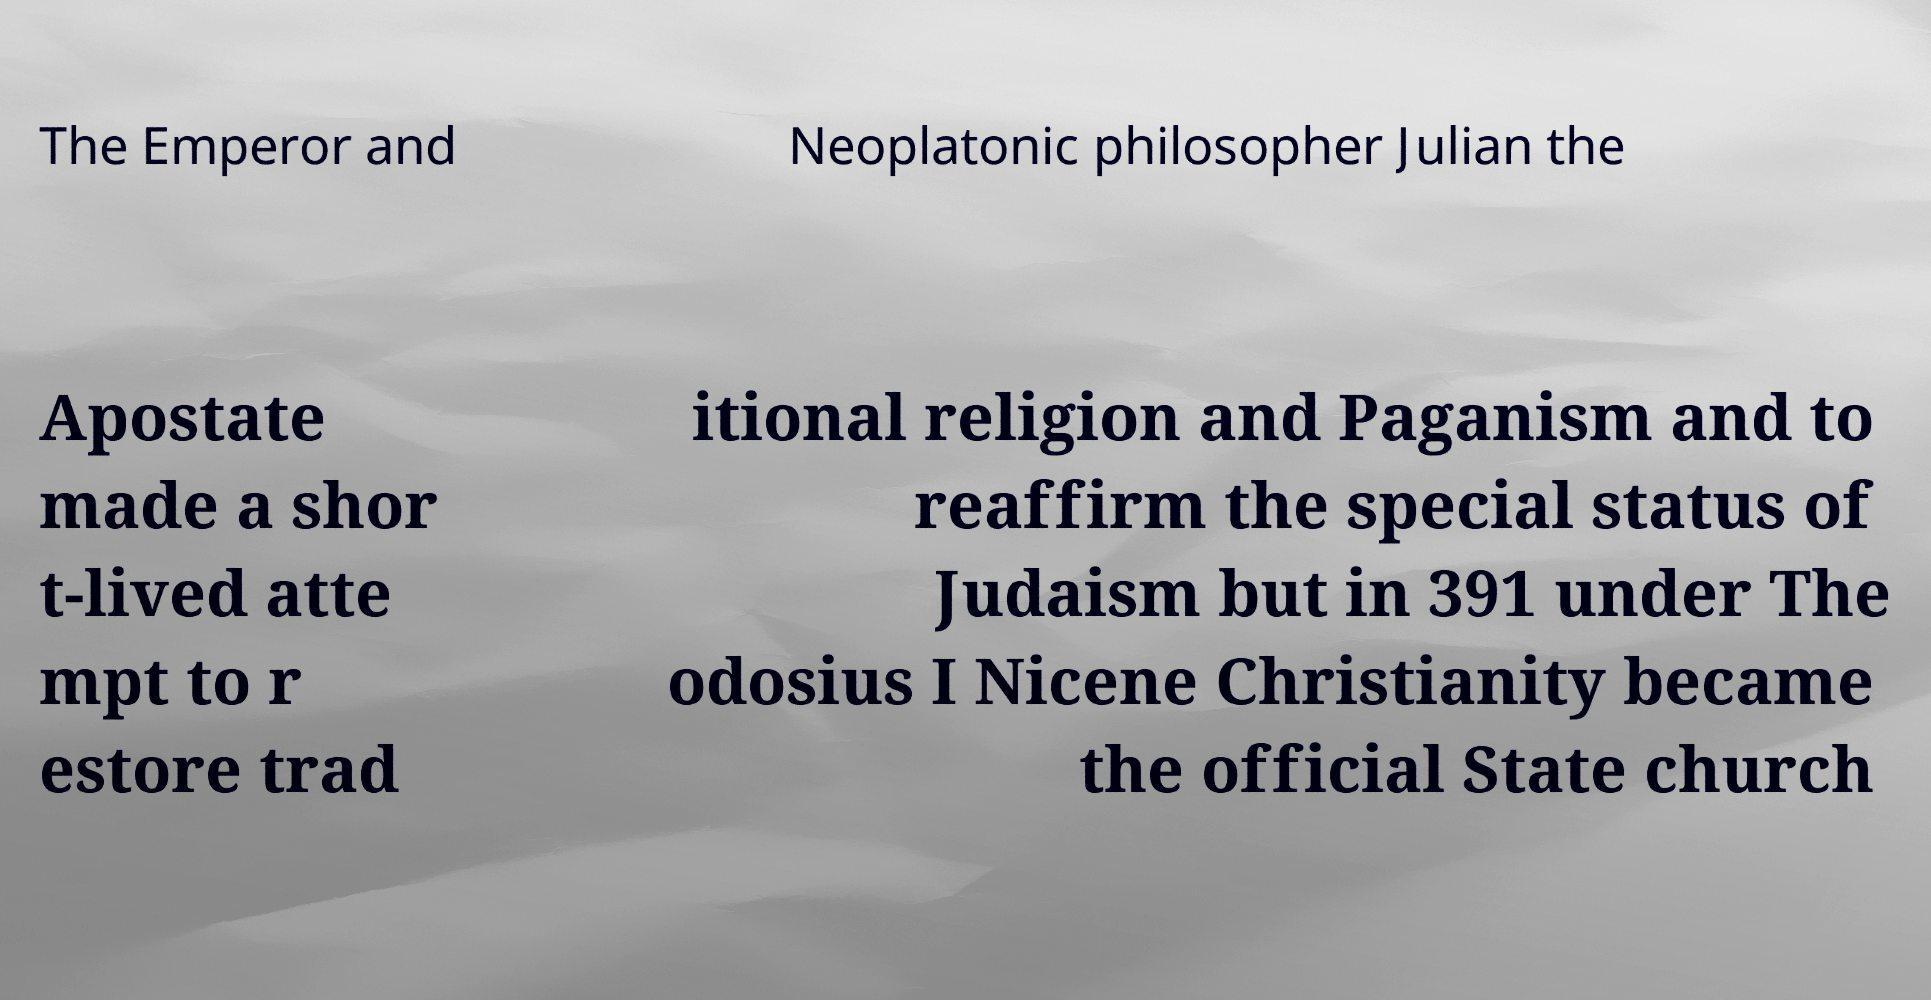Please identify and transcribe the text found in this image. The Emperor and Neoplatonic philosopher Julian the Apostate made a shor t-lived atte mpt to r estore trad itional religion and Paganism and to reaffirm the special status of Judaism but in 391 under The odosius I Nicene Christianity became the official State church 